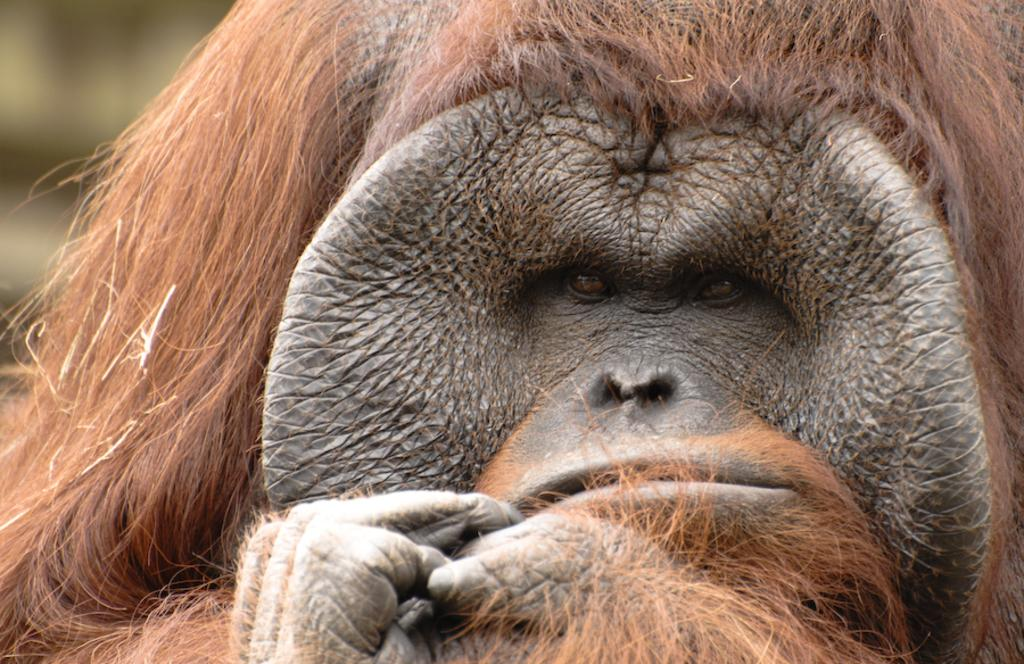What type of animal is present in the image? There is an animal in the image. Can you describe the visible part of the animal? Only the face of the animal is visible in the image. What is the color of the animal's face? The face of the animal is black in color. How many scales does the animal have on its face in the image? The animal does not have scales on its face, as it is not a reptile. What type of lunch is the animal eating in the image? The animal is not eating lunch in the image, as there is no food present. 